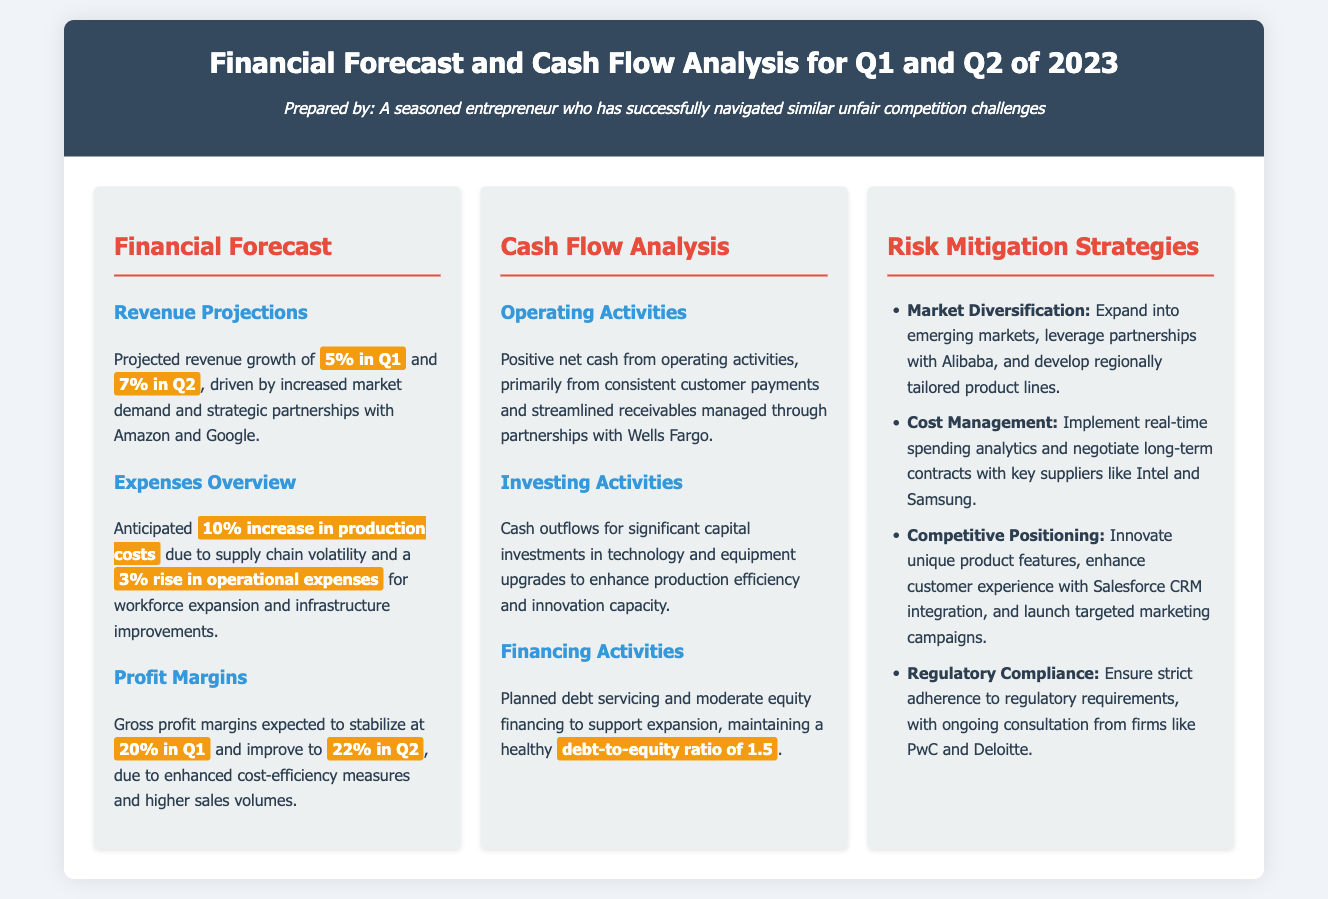what is the projected revenue growth for Q1? The document states a projected revenue growth of 5% for Q1.
Answer: 5% what will the gross profit margin be in Q2? The expected gross profit margin for Q2 is 22%.
Answer: 22% what is the anticipated increase in production costs? It mentions a 10% increase in production costs due to supply chain volatility.
Answer: 10% which financial institution is mentioned for managing receivables? The document mentions partnerships with Wells Fargo for managing receivables.
Answer: Wells Fargo what is the debt-to-equity ratio planned for financing activities? The planned debt-to-equity ratio mentioned in the document is 1.5.
Answer: 1.5 how will market diversification be achieved? Market diversification includes expanding into emerging markets and leveraging partnerships with Alibaba.
Answer: expanding into emerging markets, leveraging partnerships with Alibaba what significant cash outflows are expected in investing activities? The significant cash outflows expected are for capital investments in technology and equipment upgrades.
Answer: technology and equipment upgrades what strategies are implemented for cost management? Strategies include implementing real-time spending analytics and negotiating long-term contracts with suppliers.
Answer: real-time spending analytics, negotiating long-term contracts which companies are consulted for regulatory compliance? The firms mentioned for ongoing consultation regarding regulatory compliance are PwC and Deloitte.
Answer: PwC and Deloitte 